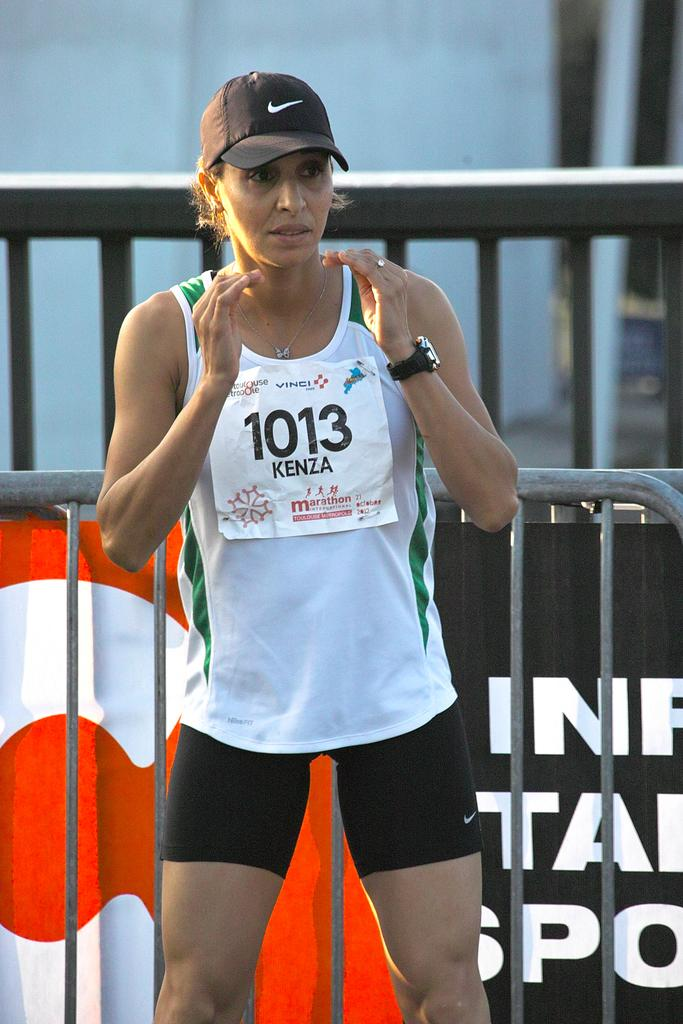<image>
Give a short and clear explanation of the subsequent image. a person that is wearing a 1013 sign on themselves 